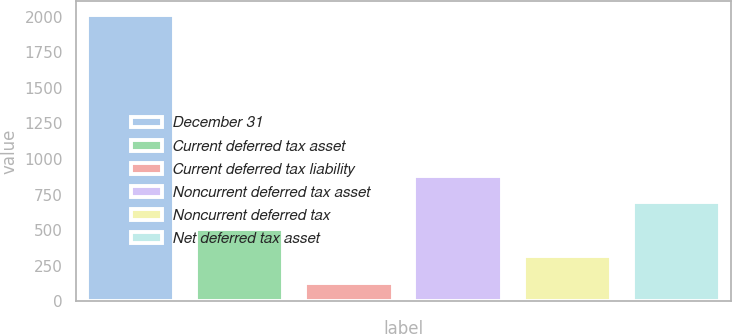Convert chart. <chart><loc_0><loc_0><loc_500><loc_500><bar_chart><fcel>December 31<fcel>Current deferred tax asset<fcel>Current deferred tax liability<fcel>Noncurrent deferred tax asset<fcel>Noncurrent deferred tax<fcel>Net deferred tax asset<nl><fcel>2011<fcel>507<fcel>131<fcel>883<fcel>319<fcel>695<nl></chart> 